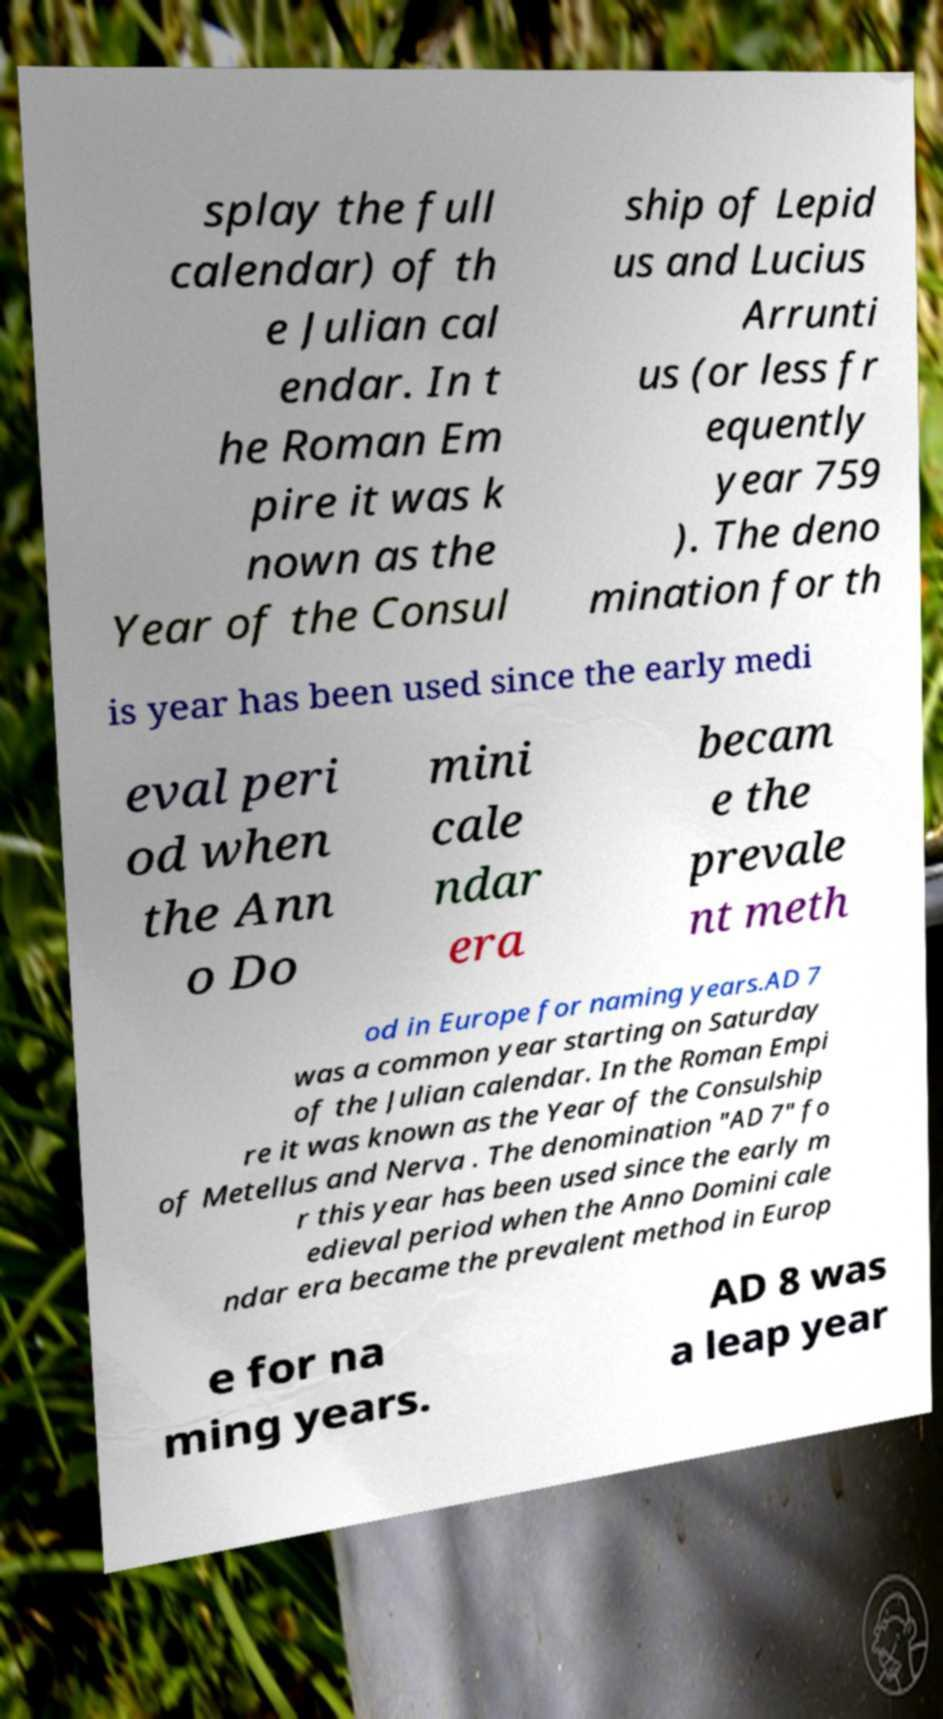Can you read and provide the text displayed in the image?This photo seems to have some interesting text. Can you extract and type it out for me? splay the full calendar) of th e Julian cal endar. In t he Roman Em pire it was k nown as the Year of the Consul ship of Lepid us and Lucius Arrunti us (or less fr equently year 759 ). The deno mination for th is year has been used since the early medi eval peri od when the Ann o Do mini cale ndar era becam e the prevale nt meth od in Europe for naming years.AD 7 was a common year starting on Saturday of the Julian calendar. In the Roman Empi re it was known as the Year of the Consulship of Metellus and Nerva . The denomination "AD 7" fo r this year has been used since the early m edieval period when the Anno Domini cale ndar era became the prevalent method in Europ e for na ming years. AD 8 was a leap year 